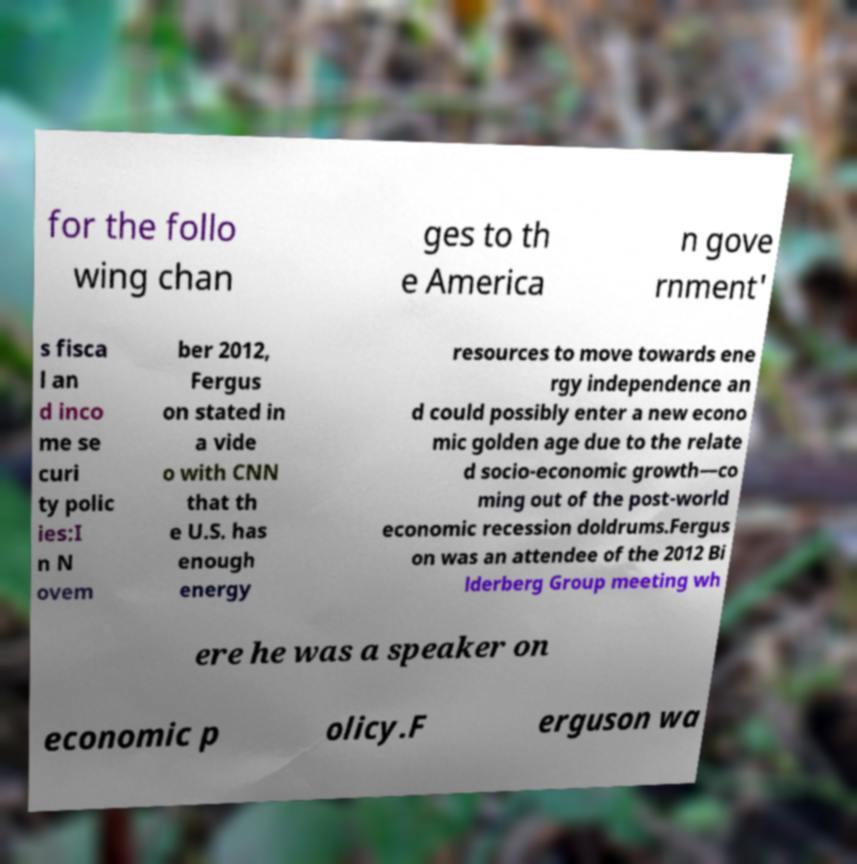Can you read and provide the text displayed in the image?This photo seems to have some interesting text. Can you extract and type it out for me? for the follo wing chan ges to th e America n gove rnment' s fisca l an d inco me se curi ty polic ies:I n N ovem ber 2012, Fergus on stated in a vide o with CNN that th e U.S. has enough energy resources to move towards ene rgy independence an d could possibly enter a new econo mic golden age due to the relate d socio-economic growth—co ming out of the post-world economic recession doldrums.Fergus on was an attendee of the 2012 Bi lderberg Group meeting wh ere he was a speaker on economic p olicy.F erguson wa 